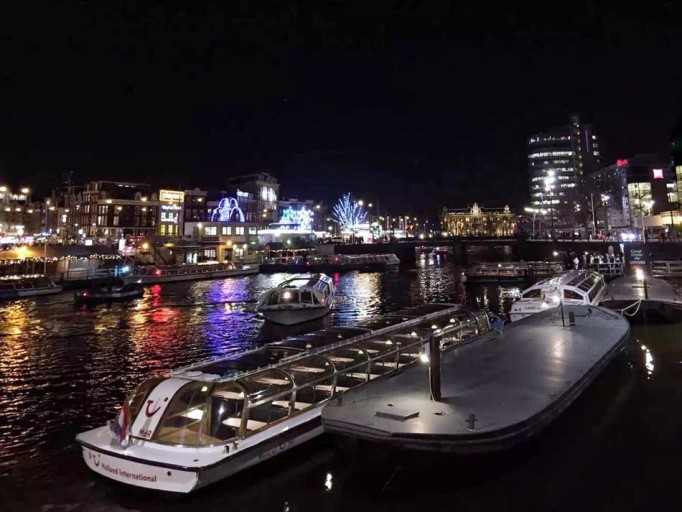Can you describe the activities that might be going on in this location? Given the lighting and calmness of the water, it could be a location frequented for evening pleasure cruises, romantic boat rides, or nighttime sightseeing tours along the waterways. 